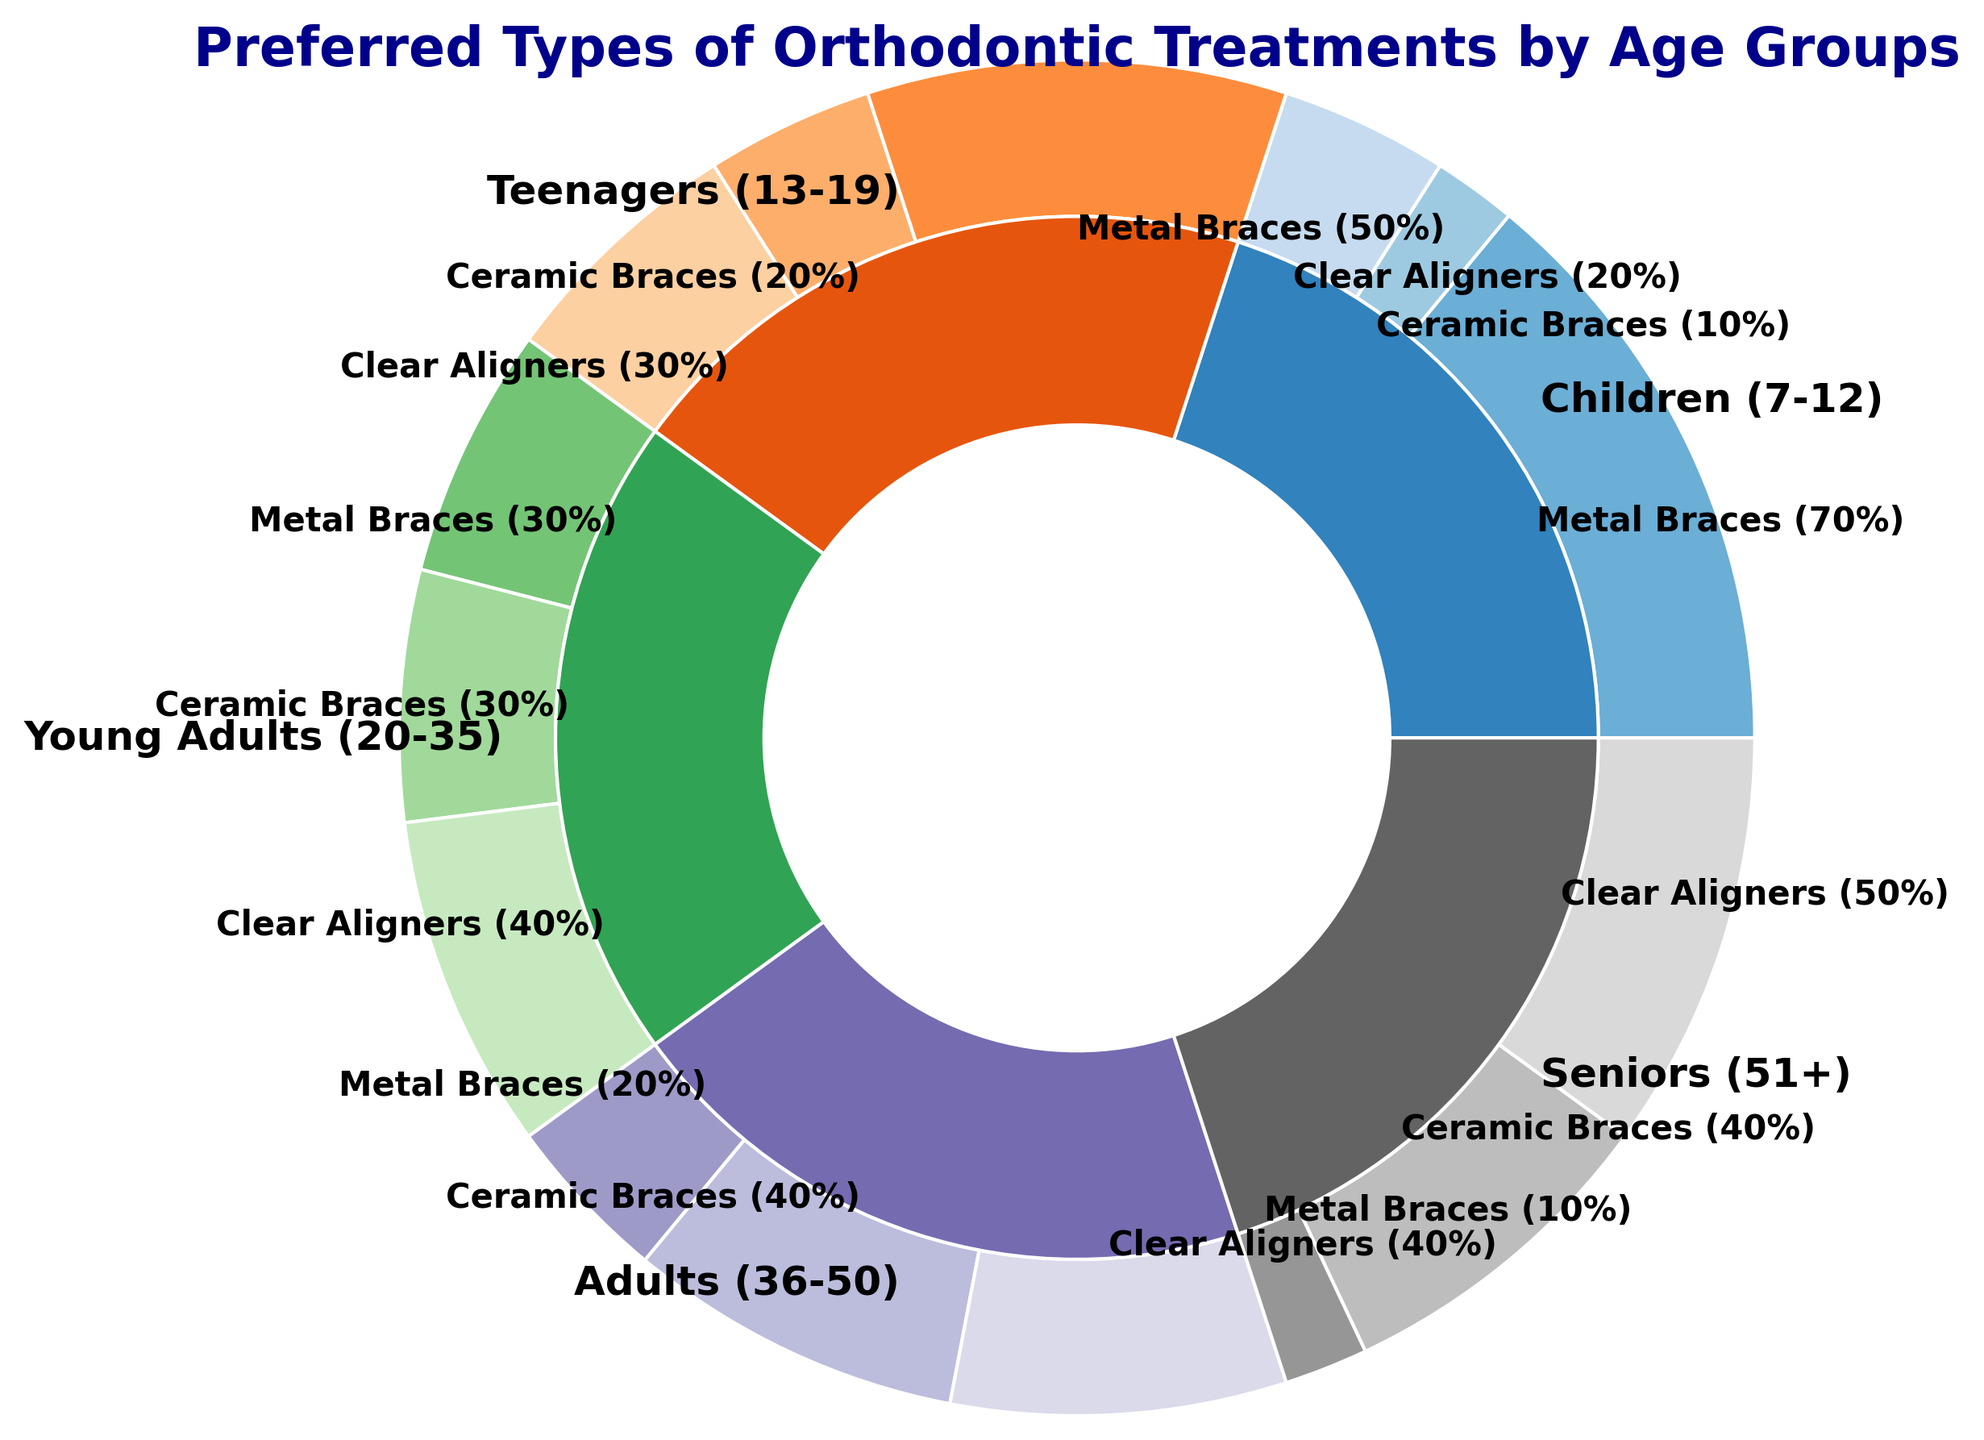What percentage of children (7-12) use metal braces? The figure shows the percentage breakdown of different treatment types within the children (7-12) category. The segment corresponding to metal braces shows 70%.
Answer: 70% Which age group has the highest preference for clear aligners? To find this, look at the clear aligner segments for all age groups. The seniors (51+) segment is the largest for clear aligners with 50%.
Answer: Seniors (51+) How many age groups have a higher preference for ceramic braces over metal braces? Compare the ceramic and metal brace segments for each age group. Young Adults (20-35), Adults (36-50), and Seniors (51+) have higher ceramic braces preferences. That gives three age groups.
Answer: 3 Which age group shows equal preference between ceramic braces and clear aligners? Look for age groups where ceramic braces and clear aligners have the same segment size. Both Adults (36-50) have equal preferences for ceramic braces (40%) and clear aligners (40%).
Answer: Adults (36-50) What is the combined percentage of teenagers (13-19) using either ceramic braces or clear aligners? Add the percentages for ceramic braces (20%) and clear aligners (30%) in the teenager group. 20% + 30% = 50%.
Answer: 50% What is the ratio of metal braces to ceramic braces for young adults (20-35)? The percentage for metal braces in young adults is 30%, and for ceramic braces, it is also 30%. So, the ratio is 30:30, which simplifies to 1:1.
Answer: 1:1 If you combine the percentages of clear aligners used by both the children's group and teenagers' group, what is the resultant percentage? Add the clear aligner percentages of children (20%) and teenagers (30%). 20% + 30% = 50%.
Answer: 50% Which treatment type shows the most balanced distribution across all age groups? Look at the segments for each treatment type and compare their sizes across different age groups. Ceramic braces have relatively balanced values across the age groups compared to metal braces and clear aligners.
Answer: Ceramic braces In which age group are metal braces the least preferred, and what is the percentage? Look for the smallest segment corresponding to metal braces across all age groups. The seniors (51+) age group has the smallest at 10%.
Answer: Seniors (51+), 10% How does the preference for clear aligners change from young adults (20-35) to seniors (51+)? Compare the clear aligner segments of young adults (40%) and seniors (50%). There is an increase from 40% to 50%, meaning a 10 percentage point increase.
Answer: Increases by 10% 